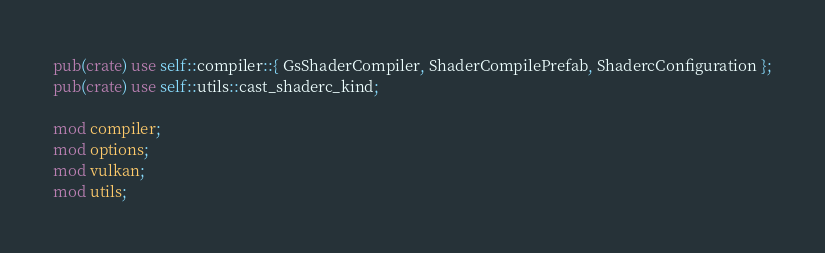Convert code to text. <code><loc_0><loc_0><loc_500><loc_500><_Rust_>
pub(crate) use self::compiler::{ GsShaderCompiler, ShaderCompilePrefab, ShadercConfiguration };
pub(crate) use self::utils::cast_shaderc_kind;

mod compiler;
mod options;
mod vulkan;
mod utils;
</code> 